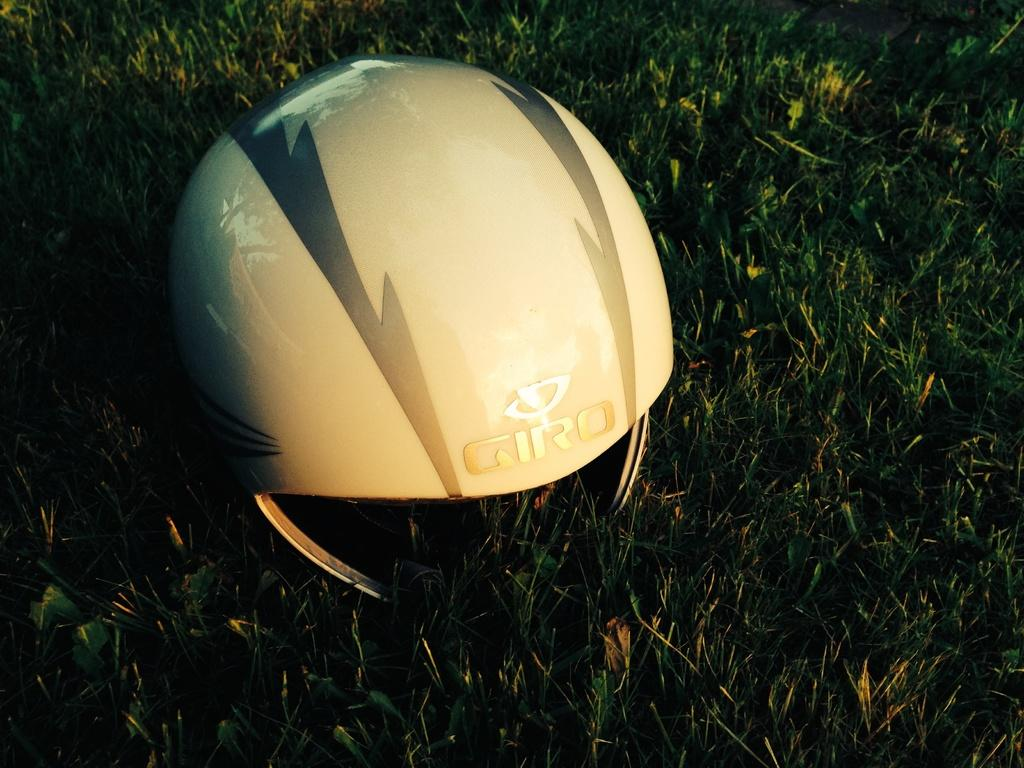What object is on the ground in the image? There is a helmet on the ground. What type of vegetation is present in the image? There is grass in the image. Where is the woman using the faucet in the image? There is no woman or faucet present in the image. 